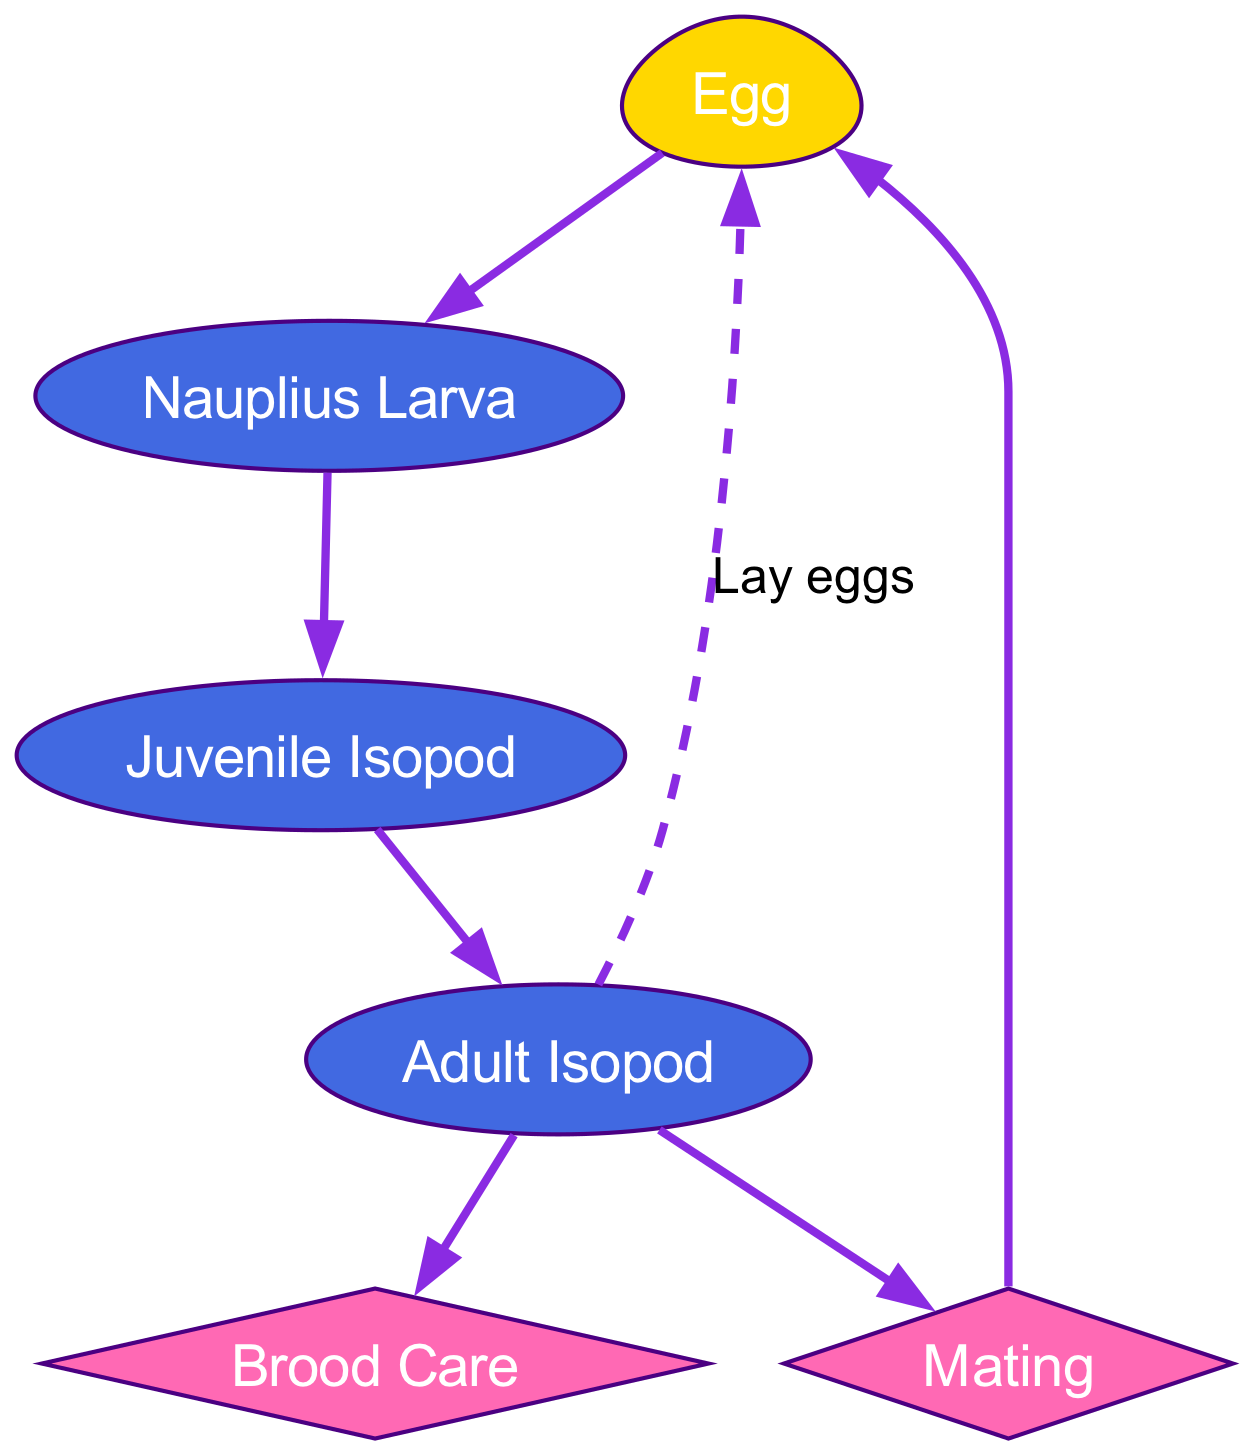What is the starting point of the life cycle? The diagram indicates that the starting point of the life cycle is the "Egg" node.
Answer: Egg How many stages are there from Egg to Adult Isopod? The diagram shows three stages: Egg → Nauplius Larva → Juvenile Isopod → Adult Isopod, which totals three distinct stages.
Answer: 3 What occurs after Mating? Based on the diagram, after "Mating," the flow leads to the "Egg," indicating that the next step is the formation of eggs.
Answer: Egg Which node indicates parental care? The "Brood Care" node in the diagram specifically represents the stage where parental care is provided.
Answer: Brood Care How many edges are outgoing from the Adult Isopod node? The "Adult Isopod" node has three outgoing edges: one to "Mating," one to "Brood Care," and one to "Egg." This totals three edges.
Answer: 3 Which two nodes are directly connected by the edge labeled 'Lay eggs'? The edge labeled 'Lay eggs' directly connects the nodes "Adult Isopod" and "Egg."
Answer: Adult Isopod, Egg What type of node is 'Mating' classified as in the diagram? In the diagram, the 'Mating' node is classified as a diamond shape, indicating a decision or a specific juncture in the life cycle.
Answer: Diamond How is the relationship between Juvenile Isopod and Adult Isopod represented? The relationship is represented by a direct edge pointing from "Juvenile Isopod" to "Adult Isopod," indicating a progression in the life cycle.
Answer: Direct edge Which node leads back to the Egg after Mating? The diagram clearly shows that "Mating" leads back to the "Egg" node.
Answer: Egg 